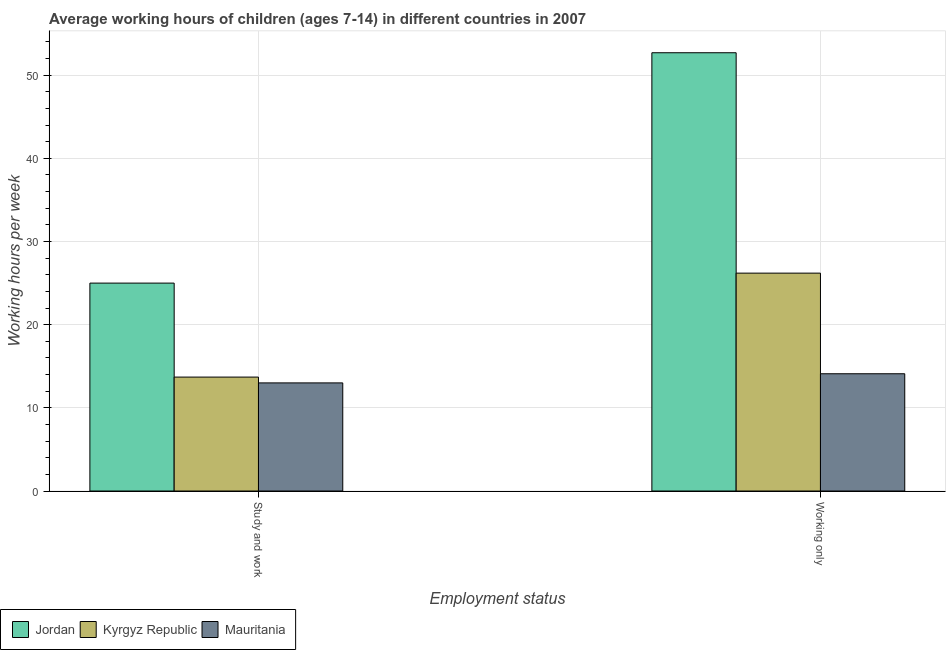Are the number of bars on each tick of the X-axis equal?
Your answer should be very brief. Yes. How many bars are there on the 1st tick from the right?
Your answer should be very brief. 3. What is the label of the 1st group of bars from the left?
Offer a terse response. Study and work. What is the average working hour of children involved in only work in Kyrgyz Republic?
Make the answer very short. 26.2. Across all countries, what is the maximum average working hour of children involved in only work?
Ensure brevity in your answer.  52.7. Across all countries, what is the minimum average working hour of children involved in only work?
Offer a very short reply. 14.1. In which country was the average working hour of children involved in study and work maximum?
Your answer should be compact. Jordan. In which country was the average working hour of children involved in only work minimum?
Your answer should be compact. Mauritania. What is the total average working hour of children involved in study and work in the graph?
Provide a succinct answer. 51.7. What is the average average working hour of children involved in study and work per country?
Your answer should be compact. 17.23. What is the difference between the average working hour of children involved in study and work and average working hour of children involved in only work in Mauritania?
Keep it short and to the point. -1.1. In how many countries, is the average working hour of children involved in only work greater than 18 hours?
Provide a short and direct response. 2. What is the ratio of the average working hour of children involved in study and work in Kyrgyz Republic to that in Jordan?
Provide a short and direct response. 0.55. In how many countries, is the average working hour of children involved in only work greater than the average average working hour of children involved in only work taken over all countries?
Make the answer very short. 1. What does the 1st bar from the left in Study and work represents?
Your answer should be compact. Jordan. What does the 2nd bar from the right in Working only represents?
Give a very brief answer. Kyrgyz Republic. Are all the bars in the graph horizontal?
Give a very brief answer. No. How many countries are there in the graph?
Your answer should be compact. 3. Are the values on the major ticks of Y-axis written in scientific E-notation?
Your response must be concise. No. How many legend labels are there?
Keep it short and to the point. 3. How are the legend labels stacked?
Offer a terse response. Horizontal. What is the title of the graph?
Ensure brevity in your answer.  Average working hours of children (ages 7-14) in different countries in 2007. Does "Eritrea" appear as one of the legend labels in the graph?
Offer a terse response. No. What is the label or title of the X-axis?
Offer a very short reply. Employment status. What is the label or title of the Y-axis?
Provide a short and direct response. Working hours per week. What is the Working hours per week of Kyrgyz Republic in Study and work?
Keep it short and to the point. 13.7. What is the Working hours per week in Jordan in Working only?
Give a very brief answer. 52.7. What is the Working hours per week in Kyrgyz Republic in Working only?
Offer a terse response. 26.2. Across all Employment status, what is the maximum Working hours per week of Jordan?
Provide a succinct answer. 52.7. Across all Employment status, what is the maximum Working hours per week of Kyrgyz Republic?
Offer a very short reply. 26.2. Across all Employment status, what is the maximum Working hours per week in Mauritania?
Offer a very short reply. 14.1. Across all Employment status, what is the minimum Working hours per week of Kyrgyz Republic?
Provide a succinct answer. 13.7. Across all Employment status, what is the minimum Working hours per week in Mauritania?
Keep it short and to the point. 13. What is the total Working hours per week in Jordan in the graph?
Provide a succinct answer. 77.7. What is the total Working hours per week of Kyrgyz Republic in the graph?
Give a very brief answer. 39.9. What is the total Working hours per week of Mauritania in the graph?
Your response must be concise. 27.1. What is the difference between the Working hours per week in Jordan in Study and work and that in Working only?
Offer a very short reply. -27.7. What is the difference between the Working hours per week of Kyrgyz Republic in Study and work and that in Working only?
Offer a terse response. -12.5. What is the average Working hours per week in Jordan per Employment status?
Offer a terse response. 38.85. What is the average Working hours per week in Kyrgyz Republic per Employment status?
Offer a terse response. 19.95. What is the average Working hours per week of Mauritania per Employment status?
Provide a succinct answer. 13.55. What is the difference between the Working hours per week of Jordan and Working hours per week of Kyrgyz Republic in Study and work?
Make the answer very short. 11.3. What is the difference between the Working hours per week in Jordan and Working hours per week in Mauritania in Working only?
Provide a succinct answer. 38.6. What is the difference between the Working hours per week of Kyrgyz Republic and Working hours per week of Mauritania in Working only?
Your response must be concise. 12.1. What is the ratio of the Working hours per week in Jordan in Study and work to that in Working only?
Provide a succinct answer. 0.47. What is the ratio of the Working hours per week of Kyrgyz Republic in Study and work to that in Working only?
Provide a succinct answer. 0.52. What is the ratio of the Working hours per week of Mauritania in Study and work to that in Working only?
Offer a terse response. 0.92. What is the difference between the highest and the second highest Working hours per week of Jordan?
Provide a short and direct response. 27.7. What is the difference between the highest and the lowest Working hours per week of Jordan?
Give a very brief answer. 27.7. What is the difference between the highest and the lowest Working hours per week in Mauritania?
Give a very brief answer. 1.1. 